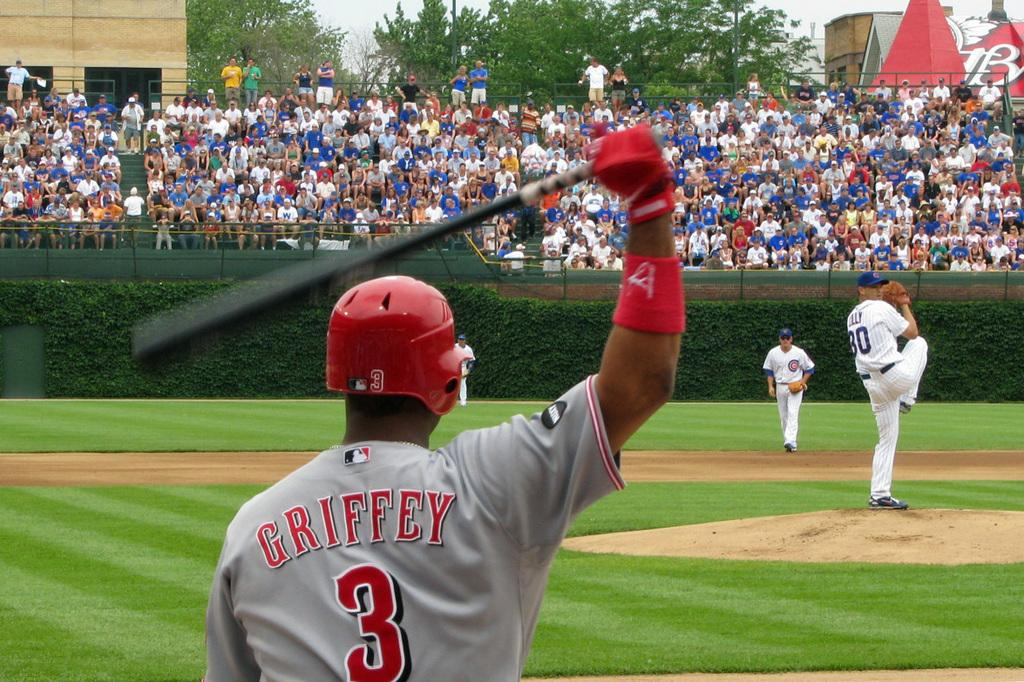<image>
Relay a brief, clear account of the picture shown. The baseball player wearing the batting helmet is number 3, griffey. 